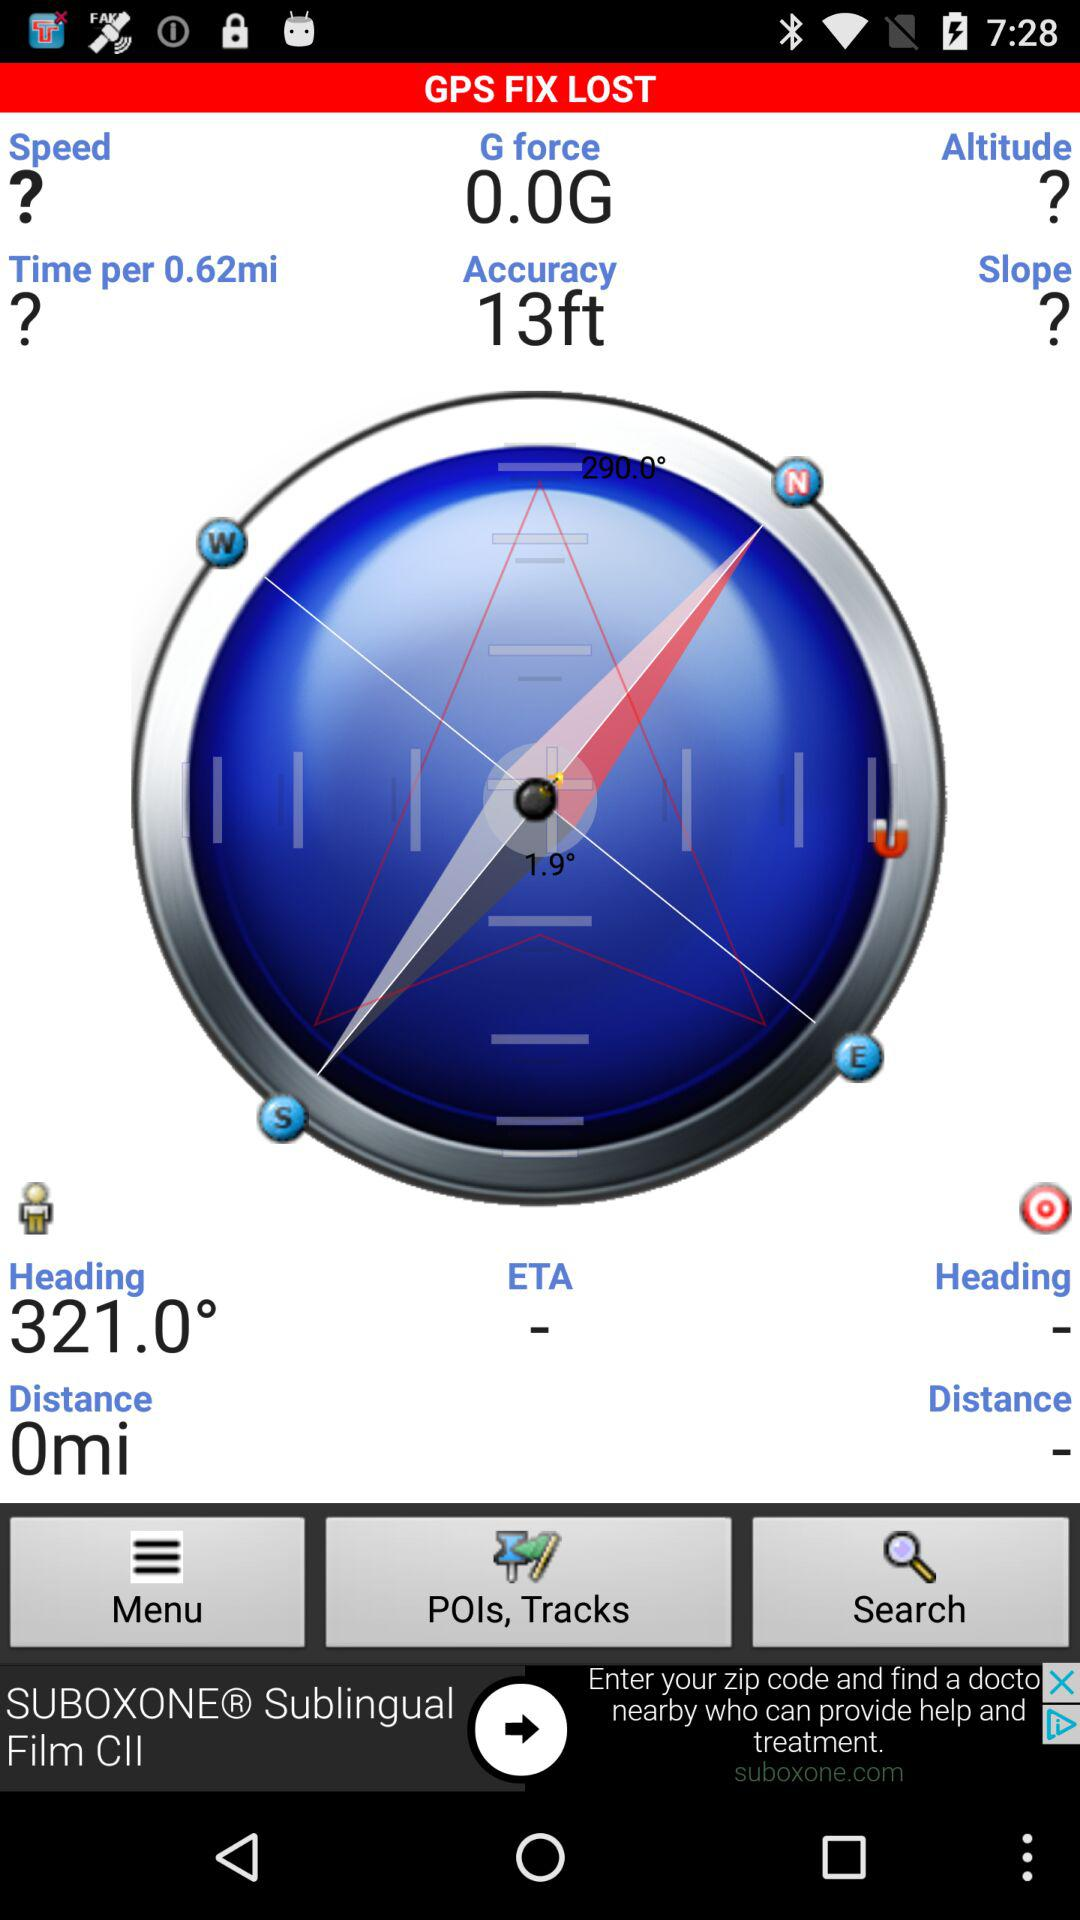What is the distance? The distance is 0 mi. 